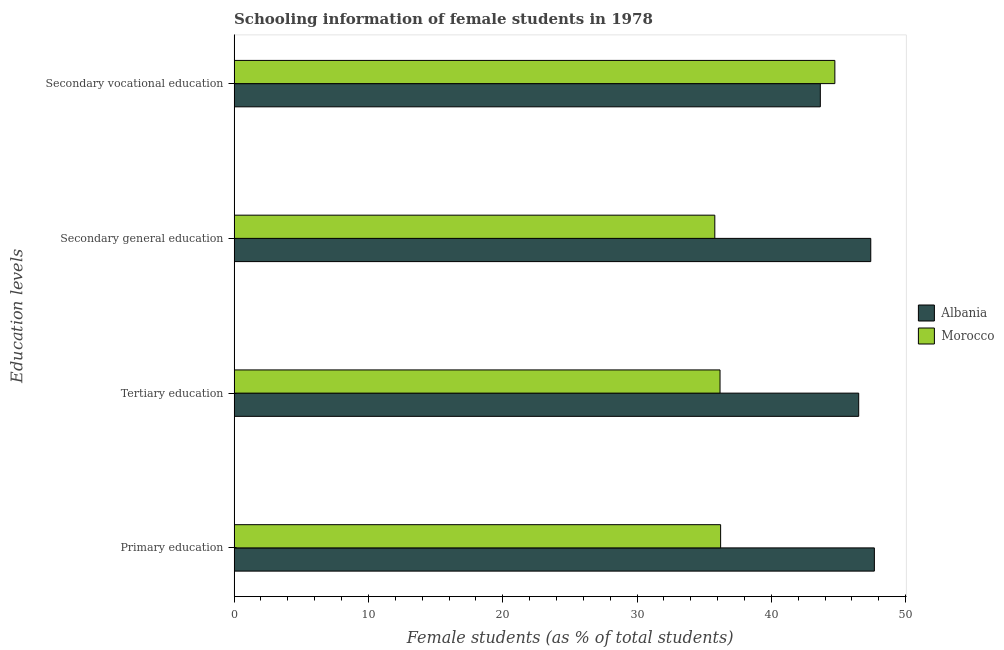Are the number of bars per tick equal to the number of legend labels?
Provide a succinct answer. Yes. Are the number of bars on each tick of the Y-axis equal?
Keep it short and to the point. Yes. How many bars are there on the 4th tick from the bottom?
Your answer should be compact. 2. What is the label of the 3rd group of bars from the top?
Your answer should be compact. Tertiary education. What is the percentage of female students in primary education in Albania?
Ensure brevity in your answer.  47.67. Across all countries, what is the maximum percentage of female students in secondary vocational education?
Ensure brevity in your answer.  44.73. Across all countries, what is the minimum percentage of female students in tertiary education?
Your response must be concise. 36.18. In which country was the percentage of female students in secondary vocational education maximum?
Keep it short and to the point. Morocco. In which country was the percentage of female students in tertiary education minimum?
Provide a succinct answer. Morocco. What is the total percentage of female students in secondary education in the graph?
Ensure brevity in your answer.  83.2. What is the difference between the percentage of female students in primary education in Albania and that in Morocco?
Provide a short and direct response. 11.45. What is the difference between the percentage of female students in secondary education in Albania and the percentage of female students in primary education in Morocco?
Your response must be concise. 11.18. What is the average percentage of female students in secondary vocational education per country?
Ensure brevity in your answer.  44.19. What is the difference between the percentage of female students in secondary education and percentage of female students in tertiary education in Morocco?
Provide a succinct answer. -0.39. In how many countries, is the percentage of female students in secondary education greater than 18 %?
Offer a very short reply. 2. What is the ratio of the percentage of female students in secondary education in Albania to that in Morocco?
Offer a very short reply. 1.32. Is the percentage of female students in primary education in Albania less than that in Morocco?
Make the answer very short. No. Is the difference between the percentage of female students in primary education in Albania and Morocco greater than the difference between the percentage of female students in tertiary education in Albania and Morocco?
Your answer should be compact. Yes. What is the difference between the highest and the second highest percentage of female students in tertiary education?
Offer a very short reply. 10.33. What is the difference between the highest and the lowest percentage of female students in primary education?
Give a very brief answer. 11.45. In how many countries, is the percentage of female students in secondary vocational education greater than the average percentage of female students in secondary vocational education taken over all countries?
Your response must be concise. 1. Is the sum of the percentage of female students in tertiary education in Albania and Morocco greater than the maximum percentage of female students in secondary vocational education across all countries?
Offer a very short reply. Yes. Is it the case that in every country, the sum of the percentage of female students in secondary education and percentage of female students in primary education is greater than the sum of percentage of female students in tertiary education and percentage of female students in secondary vocational education?
Keep it short and to the point. No. What does the 2nd bar from the top in Secondary general education represents?
Your answer should be very brief. Albania. What does the 1st bar from the bottom in Tertiary education represents?
Your response must be concise. Albania. Is it the case that in every country, the sum of the percentage of female students in primary education and percentage of female students in tertiary education is greater than the percentage of female students in secondary education?
Offer a very short reply. Yes. Are all the bars in the graph horizontal?
Provide a succinct answer. Yes. How many countries are there in the graph?
Your response must be concise. 2. What is the difference between two consecutive major ticks on the X-axis?
Provide a succinct answer. 10. Does the graph contain any zero values?
Provide a succinct answer. No. How are the legend labels stacked?
Ensure brevity in your answer.  Vertical. What is the title of the graph?
Ensure brevity in your answer.  Schooling information of female students in 1978. Does "Algeria" appear as one of the legend labels in the graph?
Make the answer very short. No. What is the label or title of the X-axis?
Provide a succinct answer. Female students (as % of total students). What is the label or title of the Y-axis?
Ensure brevity in your answer.  Education levels. What is the Female students (as % of total students) in Albania in Primary education?
Ensure brevity in your answer.  47.67. What is the Female students (as % of total students) in Morocco in Primary education?
Your answer should be very brief. 36.22. What is the Female students (as % of total students) in Albania in Tertiary education?
Your answer should be very brief. 46.51. What is the Female students (as % of total students) in Morocco in Tertiary education?
Offer a very short reply. 36.18. What is the Female students (as % of total students) in Albania in Secondary general education?
Your answer should be compact. 47.4. What is the Female students (as % of total students) in Morocco in Secondary general education?
Offer a very short reply. 35.79. What is the Female students (as % of total students) of Albania in Secondary vocational education?
Your answer should be compact. 43.65. What is the Female students (as % of total students) of Morocco in Secondary vocational education?
Your answer should be compact. 44.73. Across all Education levels, what is the maximum Female students (as % of total students) of Albania?
Offer a very short reply. 47.67. Across all Education levels, what is the maximum Female students (as % of total students) in Morocco?
Your answer should be very brief. 44.73. Across all Education levels, what is the minimum Female students (as % of total students) in Albania?
Give a very brief answer. 43.65. Across all Education levels, what is the minimum Female students (as % of total students) in Morocco?
Your answer should be very brief. 35.79. What is the total Female students (as % of total students) in Albania in the graph?
Make the answer very short. 185.23. What is the total Female students (as % of total students) of Morocco in the graph?
Make the answer very short. 152.93. What is the difference between the Female students (as % of total students) in Albania in Primary education and that in Tertiary education?
Make the answer very short. 1.17. What is the difference between the Female students (as % of total students) in Morocco in Primary education and that in Tertiary education?
Make the answer very short. 0.04. What is the difference between the Female students (as % of total students) in Albania in Primary education and that in Secondary general education?
Ensure brevity in your answer.  0.27. What is the difference between the Female students (as % of total students) in Morocco in Primary education and that in Secondary general education?
Your answer should be very brief. 0.43. What is the difference between the Female students (as % of total students) in Albania in Primary education and that in Secondary vocational education?
Provide a succinct answer. 4.02. What is the difference between the Female students (as % of total students) in Morocco in Primary education and that in Secondary vocational education?
Offer a terse response. -8.51. What is the difference between the Female students (as % of total students) of Albania in Tertiary education and that in Secondary general education?
Provide a succinct answer. -0.9. What is the difference between the Female students (as % of total students) of Morocco in Tertiary education and that in Secondary general education?
Make the answer very short. 0.39. What is the difference between the Female students (as % of total students) of Albania in Tertiary education and that in Secondary vocational education?
Offer a very short reply. 2.86. What is the difference between the Female students (as % of total students) of Morocco in Tertiary education and that in Secondary vocational education?
Give a very brief answer. -8.55. What is the difference between the Female students (as % of total students) of Albania in Secondary general education and that in Secondary vocational education?
Offer a very short reply. 3.76. What is the difference between the Female students (as % of total students) in Morocco in Secondary general education and that in Secondary vocational education?
Ensure brevity in your answer.  -8.94. What is the difference between the Female students (as % of total students) of Albania in Primary education and the Female students (as % of total students) of Morocco in Tertiary education?
Your answer should be compact. 11.49. What is the difference between the Female students (as % of total students) in Albania in Primary education and the Female students (as % of total students) in Morocco in Secondary general education?
Offer a very short reply. 11.88. What is the difference between the Female students (as % of total students) in Albania in Primary education and the Female students (as % of total students) in Morocco in Secondary vocational education?
Keep it short and to the point. 2.94. What is the difference between the Female students (as % of total students) of Albania in Tertiary education and the Female students (as % of total students) of Morocco in Secondary general education?
Provide a short and direct response. 10.71. What is the difference between the Female students (as % of total students) of Albania in Tertiary education and the Female students (as % of total students) of Morocco in Secondary vocational education?
Your response must be concise. 1.77. What is the difference between the Female students (as % of total students) in Albania in Secondary general education and the Female students (as % of total students) in Morocco in Secondary vocational education?
Keep it short and to the point. 2.67. What is the average Female students (as % of total students) of Albania per Education levels?
Your response must be concise. 46.31. What is the average Female students (as % of total students) in Morocco per Education levels?
Keep it short and to the point. 38.23. What is the difference between the Female students (as % of total students) of Albania and Female students (as % of total students) of Morocco in Primary education?
Keep it short and to the point. 11.45. What is the difference between the Female students (as % of total students) of Albania and Female students (as % of total students) of Morocco in Tertiary education?
Give a very brief answer. 10.33. What is the difference between the Female students (as % of total students) in Albania and Female students (as % of total students) in Morocco in Secondary general education?
Make the answer very short. 11.61. What is the difference between the Female students (as % of total students) in Albania and Female students (as % of total students) in Morocco in Secondary vocational education?
Ensure brevity in your answer.  -1.08. What is the ratio of the Female students (as % of total students) in Albania in Primary education to that in Tertiary education?
Offer a terse response. 1.03. What is the ratio of the Female students (as % of total students) of Morocco in Primary education to that in Secondary general education?
Your answer should be compact. 1.01. What is the ratio of the Female students (as % of total students) in Albania in Primary education to that in Secondary vocational education?
Offer a terse response. 1.09. What is the ratio of the Female students (as % of total students) of Morocco in Primary education to that in Secondary vocational education?
Make the answer very short. 0.81. What is the ratio of the Female students (as % of total students) in Morocco in Tertiary education to that in Secondary general education?
Provide a succinct answer. 1.01. What is the ratio of the Female students (as % of total students) of Albania in Tertiary education to that in Secondary vocational education?
Make the answer very short. 1.07. What is the ratio of the Female students (as % of total students) of Morocco in Tertiary education to that in Secondary vocational education?
Provide a short and direct response. 0.81. What is the ratio of the Female students (as % of total students) of Albania in Secondary general education to that in Secondary vocational education?
Provide a short and direct response. 1.09. What is the ratio of the Female students (as % of total students) of Morocco in Secondary general education to that in Secondary vocational education?
Your response must be concise. 0.8. What is the difference between the highest and the second highest Female students (as % of total students) of Albania?
Provide a short and direct response. 0.27. What is the difference between the highest and the second highest Female students (as % of total students) of Morocco?
Provide a short and direct response. 8.51. What is the difference between the highest and the lowest Female students (as % of total students) of Albania?
Ensure brevity in your answer.  4.02. What is the difference between the highest and the lowest Female students (as % of total students) in Morocco?
Ensure brevity in your answer.  8.94. 